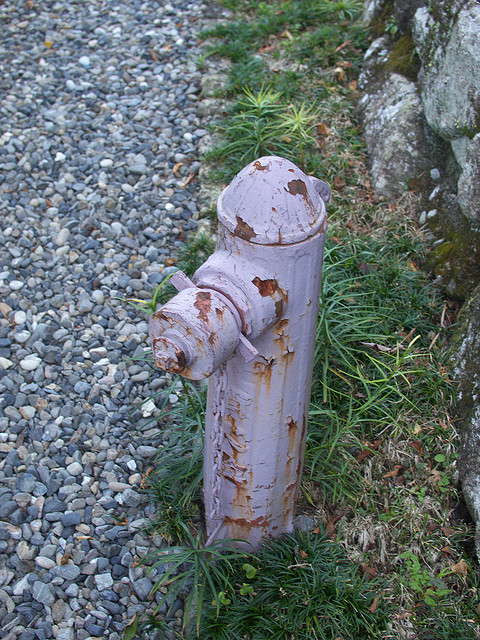Imagine if the fireplug had a story. What might it tell us about its experiences over the years? The fireplug would likely have an intriguing story to tell. It might recall the days when it was first installed, standing proudly with its fresh coat of paint. Over the years, it would have witnessed changes in its environment, perhaps seeing nearby structures built or demolished. It might have memories of children playing around it, or of being a silent sentinel during late-night patrols. The wear and chipped paint would be the marks of countless seasons of sun, rain, and maybe even snow. It's a survivor, quietly waiting for the rare moments when it is called upon to serve its crucial purpose. 